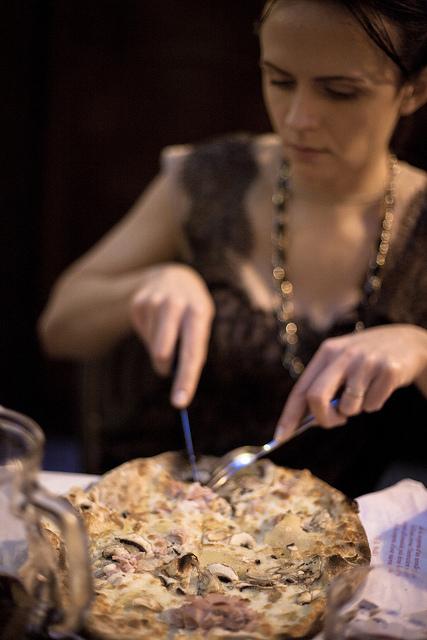Is this woman using power tools?
Give a very brief answer. No. Is this person likely married?
Quick response, please. No. Is this woman at a restaurant?
Give a very brief answer. Yes. What is the thing this woman is cutting?
Give a very brief answer. Pizza. 